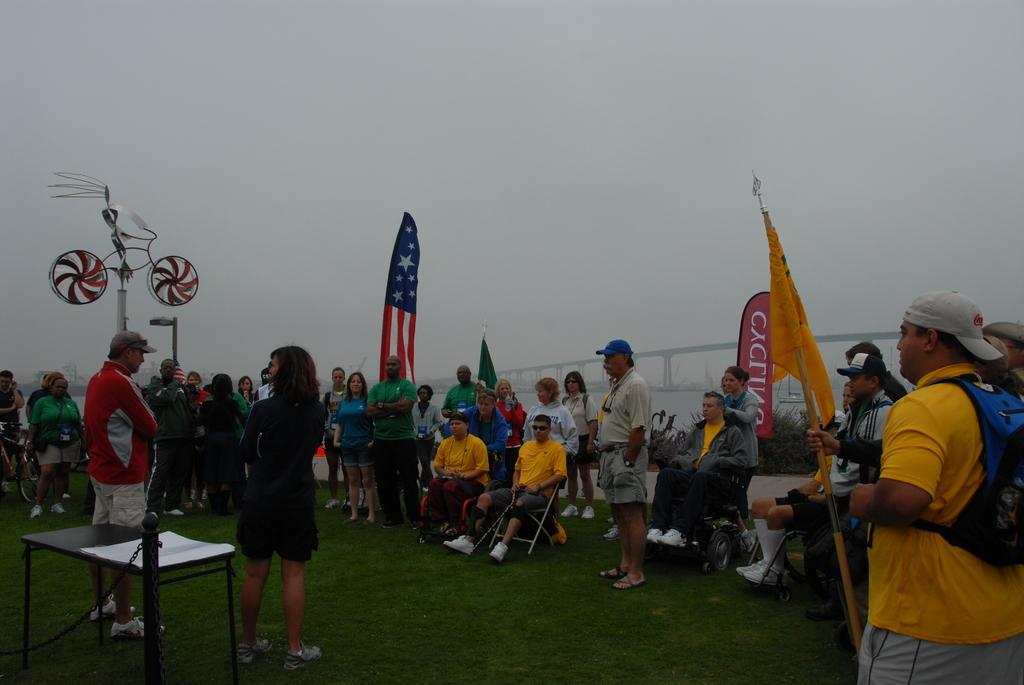How many people are in the group visible in the image? There is a group of people in the image, but the exact number is not specified. What can be seen in the image besides the group of people? There are flags, a table, a bicycle, and a banner in the image. What is located in the background of the image? There is a bridge and the sky visible in the background of the image. Can you describe the type of apparel worn by the cobweb in the image? There is no cobweb present in the image, and therefore no apparel can be described. What is the level of friction between the bicycle and the bridge in the image? The image does not provide information about the level of friction between the bicycle and the bridge, nor is there any indication that the bicycle is interacting with the bridge. 